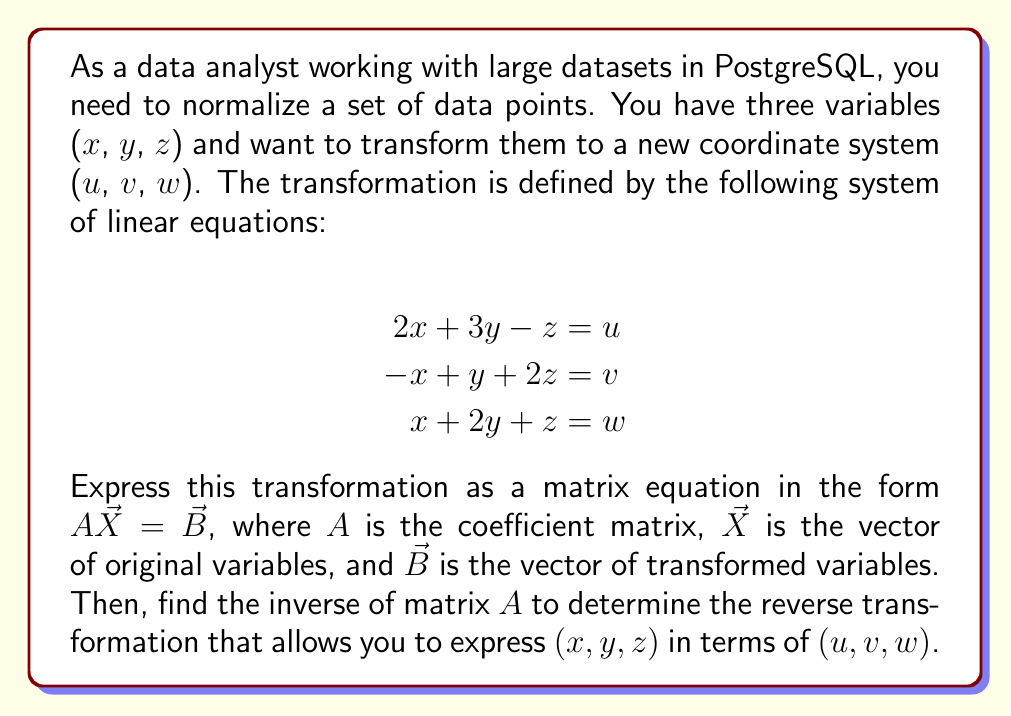Teach me how to tackle this problem. Step 1: Express the system of equations as a matrix equation.

The matrix equation $A\vec{X} = \vec{B}$ can be written as:

$$
\begin{bmatrix}
2 & 3 & -1 \\
-1 & 1 & 2 \\
1 & 2 & 1
\end{bmatrix}
\begin{bmatrix}
x \\
y \\
z
\end{bmatrix}
=
\begin{bmatrix}
u \\
v \\
w
\end{bmatrix}
$$

Step 2: Find the inverse of matrix $A$.

To find $A^{-1}$, we can use the adjugate method or Gaussian elimination. Let's use the adjugate method:

a) Calculate the determinant of $A$:
$\det(A) = 2(1-4) + 3(-3) + (-1)(-1-2) = -6 - 9 + 3 = -12$

b) Find the adjugate matrix:
$$
\text{adj}(A) = 
\begin{bmatrix}
1-4 & -(-3-2) & 3-(-2) \\
-(-1-2) & 2-(-1) & -(-3-1) \\
1-6 & -(2-3) & 2-(-1)
\end{bmatrix}
=
\begin{bmatrix}
-3 & 5 & 5 \\
3 & 3 & -4 \\
-5 & -1 & 3
\end{bmatrix}
$$

c) Calculate $A^{-1}$:
$$
A^{-1} = -\frac{1}{12}
\begin{bmatrix}
-3 & 5 & 5 \\
3 & 3 & -4 \\
-5 & -1 & 3
\end{bmatrix}
=
\begin{bmatrix}
1/4 & -5/12 & -5/12 \\
-1/4 & -1/4 & 1/3 \\
5/12 & 1/12 & -1/4
\end{bmatrix}
$$

Step 3: Express (x, y, z) in terms of (u, v, w).

Using the inverse matrix, we can now write:

$$
\begin{bmatrix}
x \\
y \\
z
\end{bmatrix}
=
\begin{bmatrix}
1/4 & -5/12 & -5/12 \\
-1/4 & -1/4 & 1/3 \\
5/12 & 1/12 & -1/4
\end{bmatrix}
\begin{bmatrix}
u \\
v \\
w
\end{bmatrix}
$$

This gives us the reverse transformation equations:

$$
\begin{align}
x &= \frac{1}{4}u - \frac{5}{12}v - \frac{5}{12}w \\
y &= -\frac{1}{4}u - \frac{1}{4}v + \frac{1}{3}w \\
z &= \frac{5}{12}u + \frac{1}{12}v - \frac{1}{4}w
\end{align}
$$
Answer: $A = \begin{bmatrix}
2 & 3 & -1 \\
-1 & 1 & 2 \\
1 & 2 & 1
\end{bmatrix}$, $A^{-1} = \begin{bmatrix}
1/4 & -5/12 & -5/12 \\
-1/4 & -1/4 & 1/3 \\
5/12 & 1/12 & -1/4
\end{bmatrix}$ 